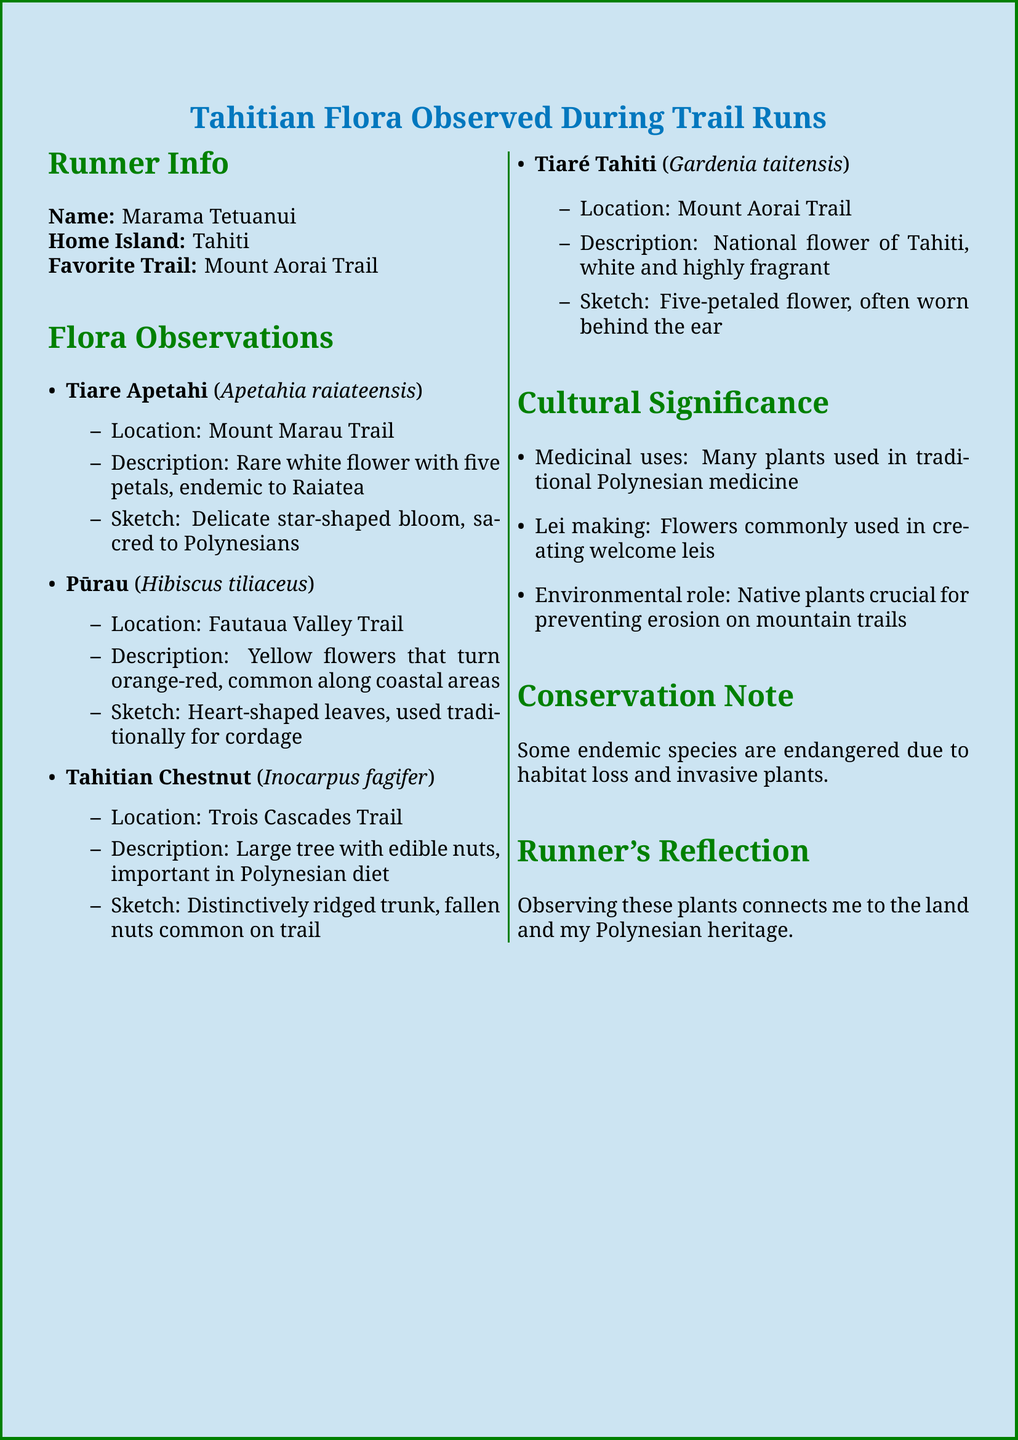what is the name of the runner? The document provides the name of the runner as Marama Tetuanui.
Answer: Marama Tetuanui what is the favorite trail of the runner? The favorite trail mentioned in the document is Mount Aorai Trail.
Answer: Mount Aorai Trail how many petals does the Tiare Tahiti flower have? The Tiare Tahiti flower is described as having five petals.
Answer: five petals what is the scientific name of the Tiare Apetahi? The scientific name provided in the document for Tiare Apetahi is Apetahia raiateensis.
Answer: Apetahia raiateensis which trail is the Pūrau observed on? The Pūrau was observed on the Fautaua Valley Trail.
Answer: Fautaua Valley Trail what role do native plants play in mountain trails? Native plants are described as crucial for preventing erosion on mountain trails.
Answer: preventing erosion what is the conservation note about? The conservation note addresses the endangerment of some endemic species due to habitat loss and invasive plants.
Answer: habitat loss and invasive plants how does observing plants relate to the runner's heritage? The runner reflects that observing these plants connects her to the land and her Polynesian heritage.
Answer: connects me to the land and my Polynesian heritage which plant is known for its distinctively ridged trunk? The Tahitian Chestnut is noted for its distinctively ridged trunk.
Answer: Tahitian Chestnut 